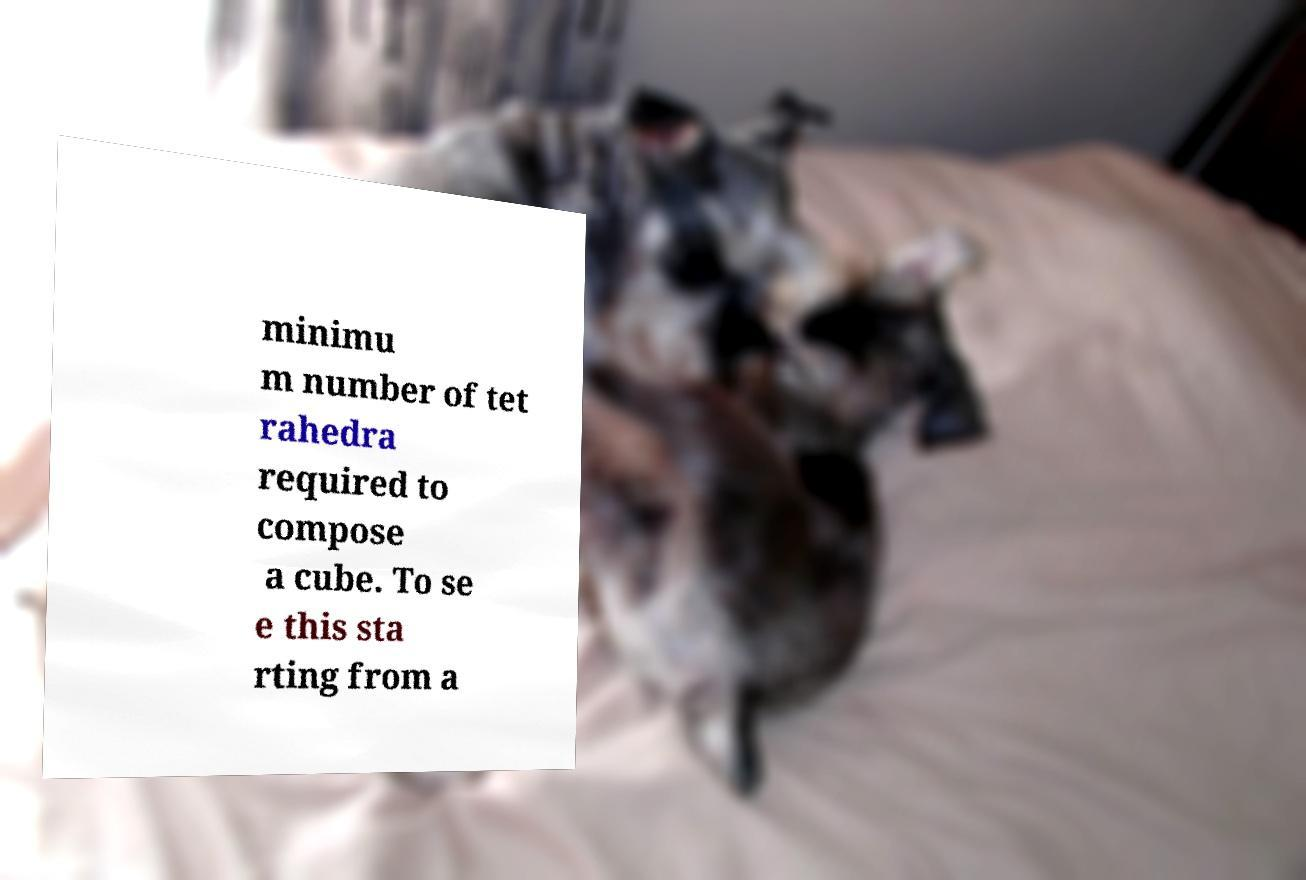Can you accurately transcribe the text from the provided image for me? minimu m number of tet rahedra required to compose a cube. To se e this sta rting from a 